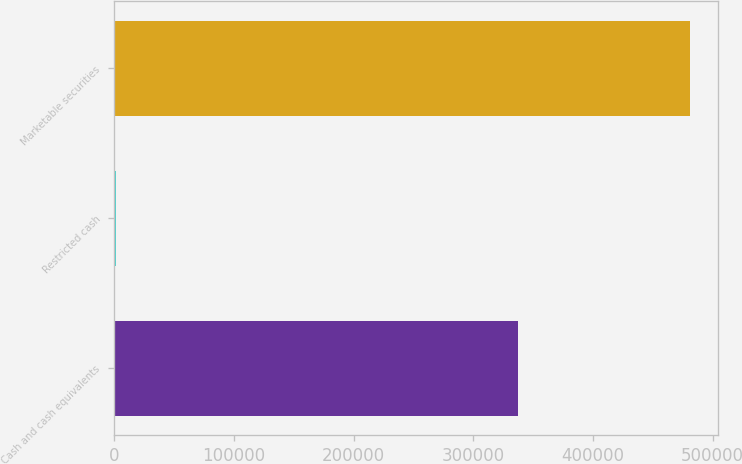Convert chart to OTSL. <chart><loc_0><loc_0><loc_500><loc_500><bar_chart><fcel>Cash and cash equivalents<fcel>Restricted cash<fcel>Marketable securities<nl><fcel>337321<fcel>1525<fcel>480876<nl></chart> 